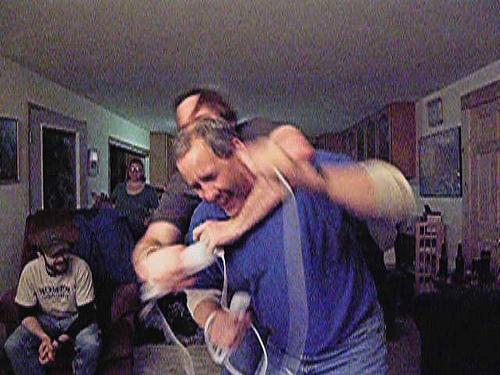What are the two men doing?
Choose the correct response and explain in the format: 'Answer: answer
Rationale: rationale.'
Options: Heimlich, hugging, wrestling, assisting. Answer: wrestling.
Rationale: The two men are wrestling in the living room. 